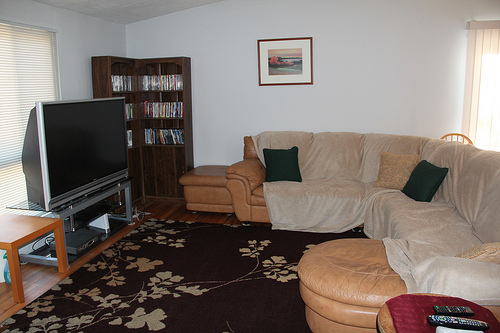Please provide a short description for this region: [0.86, 0.79, 0.98, 0.82]. The region described primarily features a sleek black remote control, likely used for operating the television. 